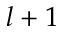<formula> <loc_0><loc_0><loc_500><loc_500>l + 1</formula> 